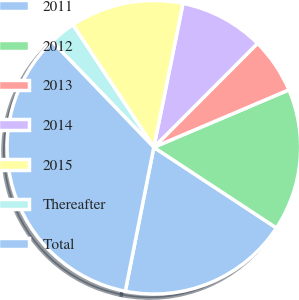Convert chart to OTSL. <chart><loc_0><loc_0><loc_500><loc_500><pie_chart><fcel>2011<fcel>2012<fcel>2013<fcel>2014<fcel>2015<fcel>Thereafter<fcel>Total<nl><fcel>18.85%<fcel>15.66%<fcel>6.12%<fcel>9.3%<fcel>12.48%<fcel>2.89%<fcel>34.7%<nl></chart> 